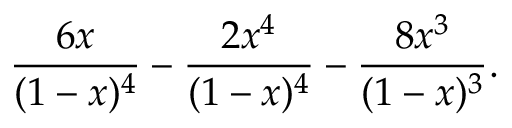<formula> <loc_0><loc_0><loc_500><loc_500>{ \frac { 6 x } { ( 1 - x ) ^ { 4 } } } - { \frac { 2 x ^ { 4 } } { ( 1 - x ) ^ { 4 } } } - { \frac { 8 x ^ { 3 } } { ( 1 - x ) ^ { 3 } } } .</formula> 